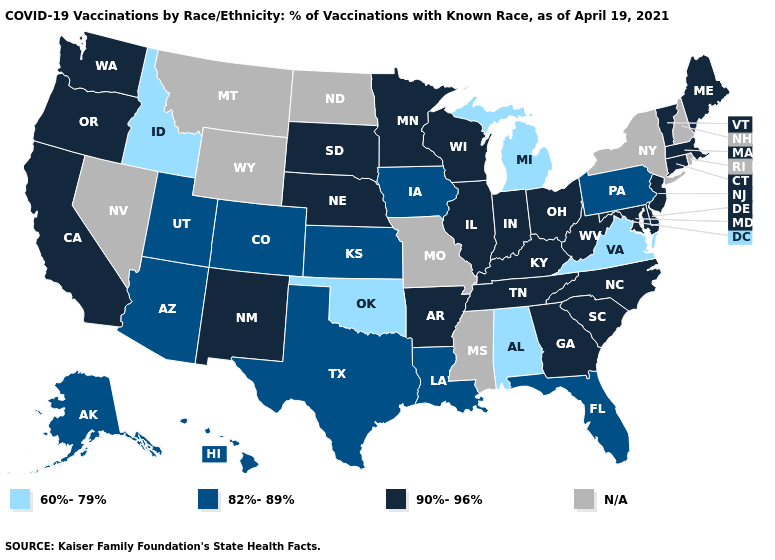What is the value of Louisiana?
Be succinct. 82%-89%. Which states have the highest value in the USA?
Quick response, please. Arkansas, California, Connecticut, Delaware, Georgia, Illinois, Indiana, Kentucky, Maine, Maryland, Massachusetts, Minnesota, Nebraska, New Jersey, New Mexico, North Carolina, Ohio, Oregon, South Carolina, South Dakota, Tennessee, Vermont, Washington, West Virginia, Wisconsin. Does the first symbol in the legend represent the smallest category?
Keep it brief. Yes. Which states have the lowest value in the West?
Answer briefly. Idaho. Name the states that have a value in the range 82%-89%?
Give a very brief answer. Alaska, Arizona, Colorado, Florida, Hawaii, Iowa, Kansas, Louisiana, Pennsylvania, Texas, Utah. Does Michigan have the lowest value in the USA?
Quick response, please. Yes. Name the states that have a value in the range 90%-96%?
Keep it brief. Arkansas, California, Connecticut, Delaware, Georgia, Illinois, Indiana, Kentucky, Maine, Maryland, Massachusetts, Minnesota, Nebraska, New Jersey, New Mexico, North Carolina, Ohio, Oregon, South Carolina, South Dakota, Tennessee, Vermont, Washington, West Virginia, Wisconsin. Which states have the lowest value in the MidWest?
Keep it brief. Michigan. What is the value of Oregon?
Concise answer only. 90%-96%. Among the states that border Michigan , which have the lowest value?
Keep it brief. Indiana, Ohio, Wisconsin. What is the lowest value in states that border Kentucky?
Write a very short answer. 60%-79%. Does Michigan have the lowest value in the MidWest?
Short answer required. Yes. Does Michigan have the lowest value in the USA?
Write a very short answer. Yes. 